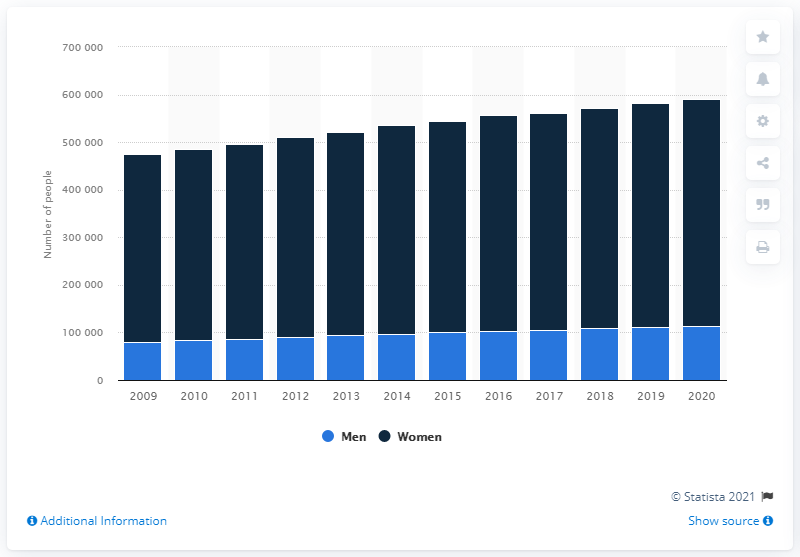Outline some significant characteristics in this image. Since 2009, the number of single mothers and fathers has been increasing. 